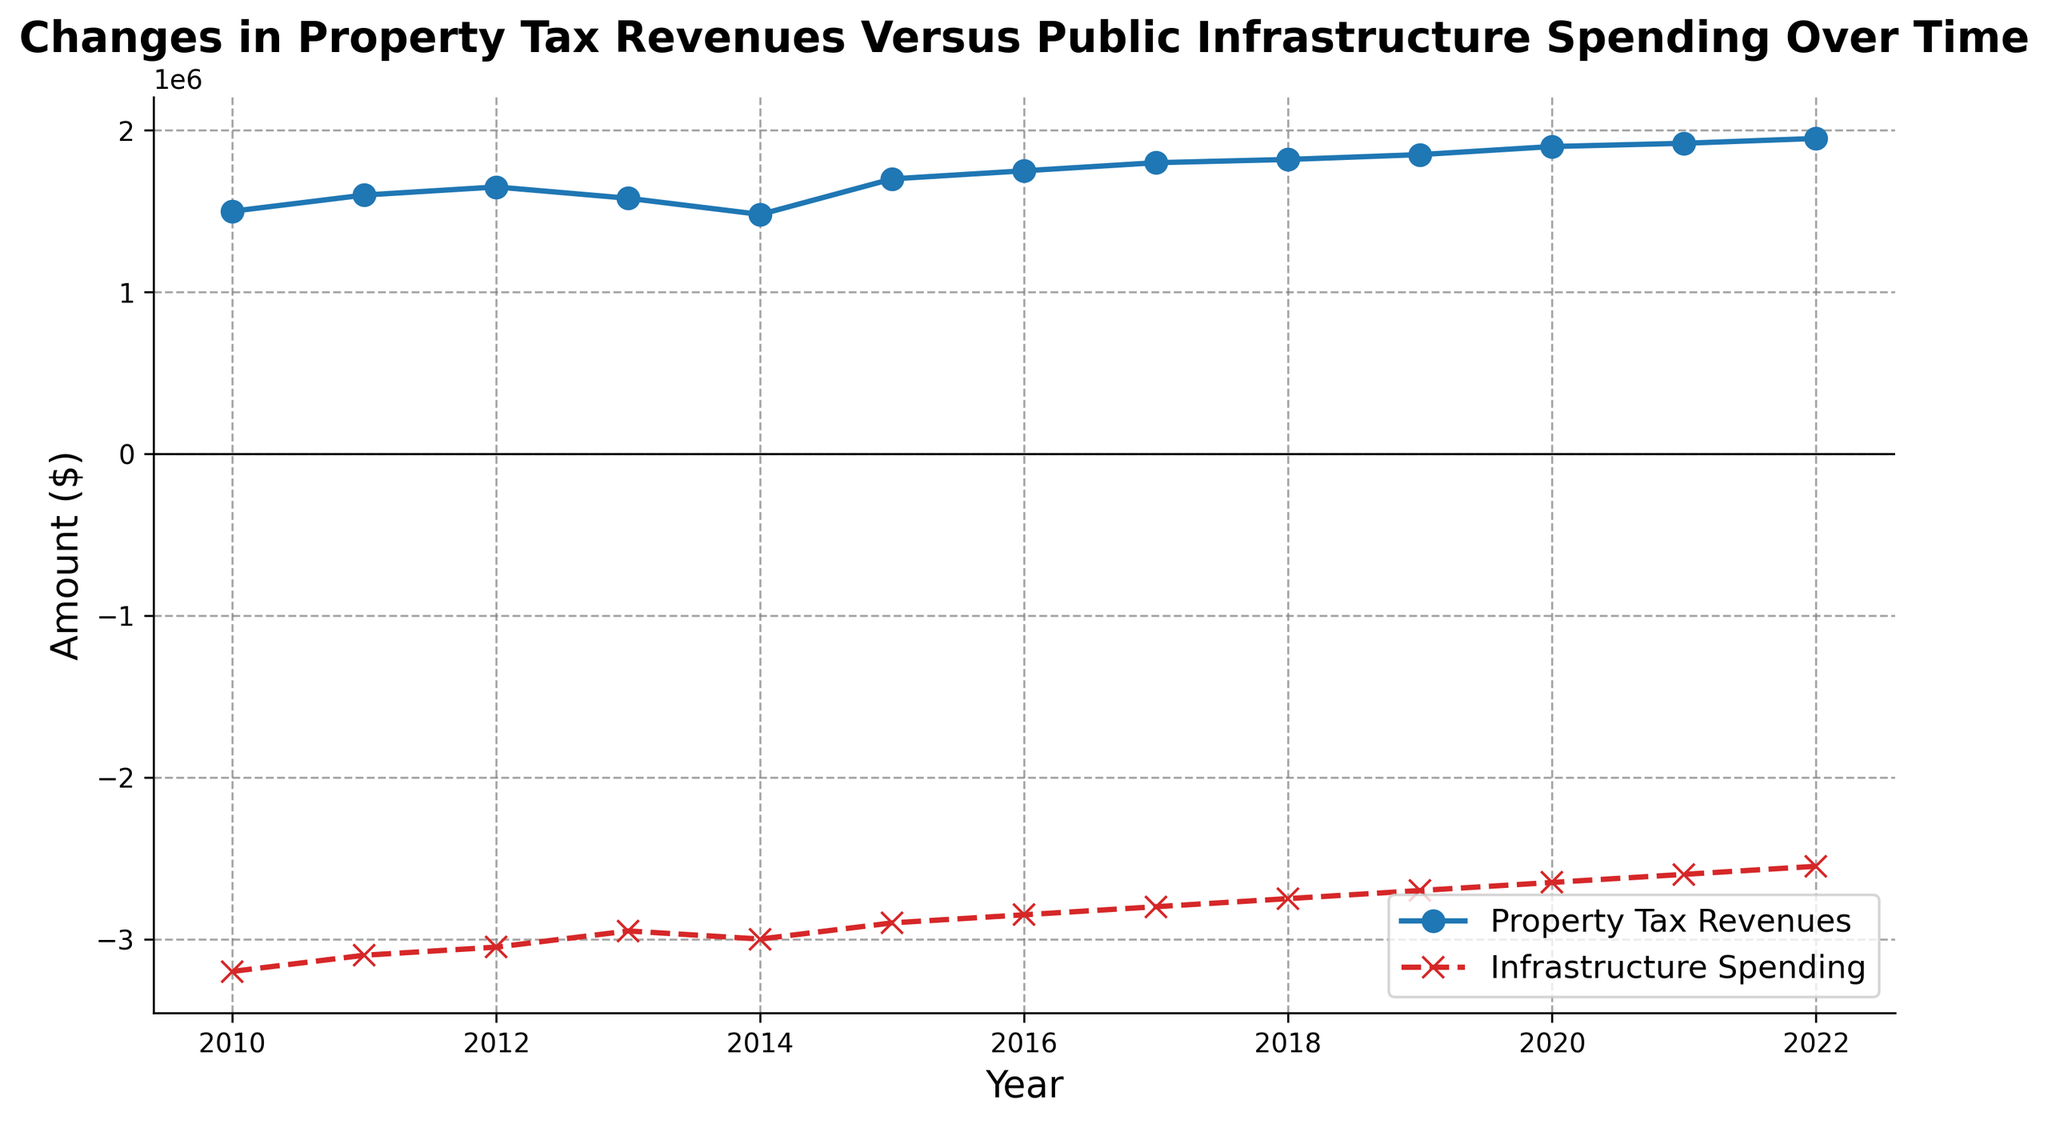What's the trend of Property Tax Revenues from 2010 to 2022? From the graph, we observe that the Property Tax Revenues show a general upward trend from 2010 to 2022, with some minor fluctuations. Specifically, the revenues increased steadily from $1,500,000 in 2010 to $1,950,000 in 2022.
Answer: Upward trend What was the highest value of Infrastructure Spending between 2010 and 2022? By examining the figure, the highest value of Infrastructure Spending occurs in 2010, with an expenditure of -$3,200,000.
Answer: -$3,200,000 In which year did Property Tax Revenues experience a noticeable decrease, and what was the value that year? From the figure, Property Tax Revenues experienced a noticeable decrease in 2013, dropping from $1,650,000 in 2012 to $1,580,000 in 2013.
Answer: 2013, $1,580,000 How did Infrastructure Spending change from 2014 to 2015, and by how much? From the graph, Infrastructure Spending decreased from -$3,000,000 in 2014 to -$2,900,000 in 2015. The change is calculated as -$3,000,000 - (-$2,900,000) = -$100,000.
Answer: Decreased by $100,000 What's the difference between Property Tax Revenues in 2010 and 2022? The Property Tax Revenues in 2010 were $1,500,000 and in 2022 were $1,950,000. The difference is $1,950,000 - $1,500,000 = $450,000.
Answer: $450,000 Which year had the smallest difference between Property Tax Revenues and Infrastructure Spending, and what was that difference? To find the smallest difference, check each year by subtracting Infrastructure Spending from Property Tax Revenues. In 2022, Property Tax Revenues were $1,950,000 and Infrastructure Spending was -$2,550,000. The smallest difference is therefore $1,950,000 - (-$2,550,000) = $4,500,000.
Answer: 2022, $4,500,000 What is the average Property Tax Revenues over the period from 2010 to 2022? Sum the Property Tax Revenues from 2010 to 2022 and divide by the number of years: ($1,500,000 + $1,600,000 + $1,650,000 + $1,580,000 + $1,480,000 + $1,700,000 + $1,750,000 + $1,800,000 + $1,820,000 + $1,850,000 + $1,900,000 + $1,920,000 + $1,950,000) / 13 = $1,736,923.08.
Answer: $1,736,923.08 Which year saw both an increase in Property Tax Revenues and a decrease in Infrastructure Spending compared to the previous year, and what were these changes? From the graph, 2015 saw an increase in Property Tax Revenues from $1,480,000 in 2014 to $1,700,000 in 2015, and a decrease in Infrastructure Spending from -$3,000,000 in 2014 to -$2,900,000 in 2015. The changes are +$220,000 for revenues and -$100,000 for spending.
Answer: 2015, +$220,000 and -$100,000 What is the compound annual growth rate (CAGR) of Property Tax Revenues from 2010 to 2022? CAGR is calculated as \( \left(\frac{{\text{{Ending Value}}}}{{\text{{Beginning Value}}}}\right)^{\frac{1}{\text{{Number of Periods}}}} - 1 \). Here, the ending value is $1,950,000, the beginning value is $1,500,000, and the number of periods is 12. \( \left(\frac{1,950,000}{1,500,000}\right)^{\frac{1}{12}} - 1 \approx 0.0206 \), so CAGR is approximately 2.06%.
Answer: 2.06% 